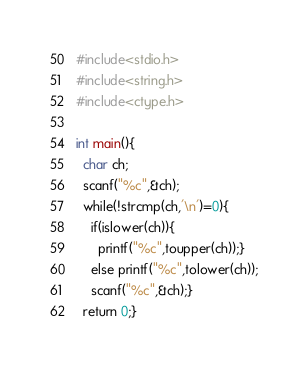<code> <loc_0><loc_0><loc_500><loc_500><_C_>#include<stdio.h>
#include<string.h>
#include<ctype.h>

int main(){
  char ch;
  scanf("%c",&ch);
  while(!strcmp(ch,'\n')=0){
    if(islower(ch)){
      printf("%c",toupper(ch));}
    else printf("%c",tolower(ch));
    scanf("%c",&ch);}
  return 0;}</code> 